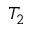Convert formula to latex. <formula><loc_0><loc_0><loc_500><loc_500>T _ { 2 }</formula> 